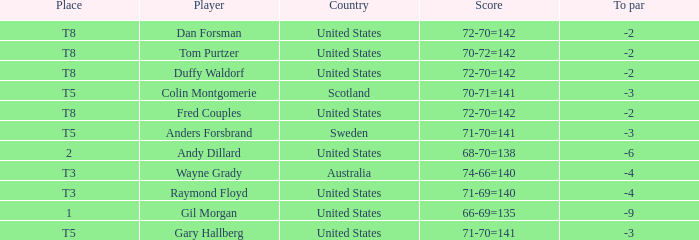What is Anders Forsbrand's Place? T5. 